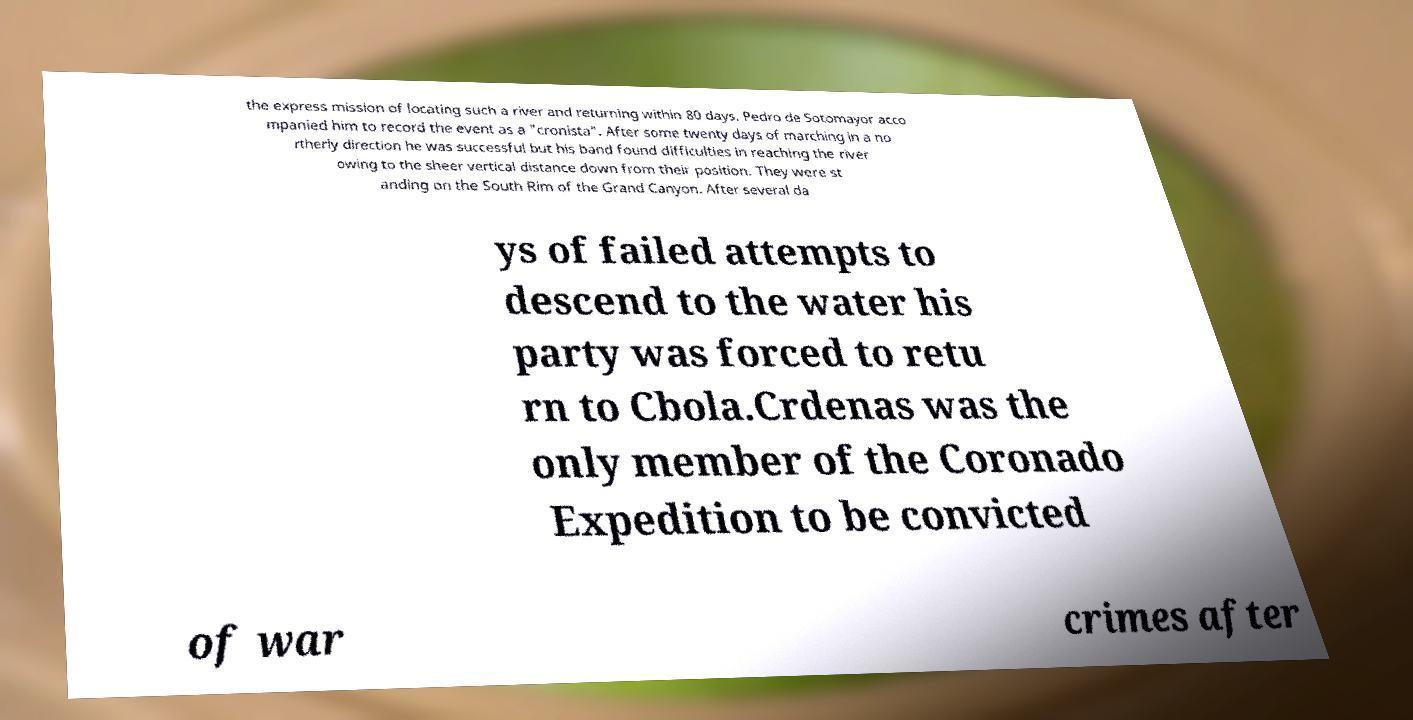Can you accurately transcribe the text from the provided image for me? the express mission of locating such a river and returning within 80 days. Pedro de Sotomayor acco mpanied him to record the event as a "cronista". After some twenty days of marching in a no rtherly direction he was successful but his band found difficulties in reaching the river owing to the sheer vertical distance down from their position. They were st anding on the South Rim of the Grand Canyon. After several da ys of failed attempts to descend to the water his party was forced to retu rn to Cbola.Crdenas was the only member of the Coronado Expedition to be convicted of war crimes after 